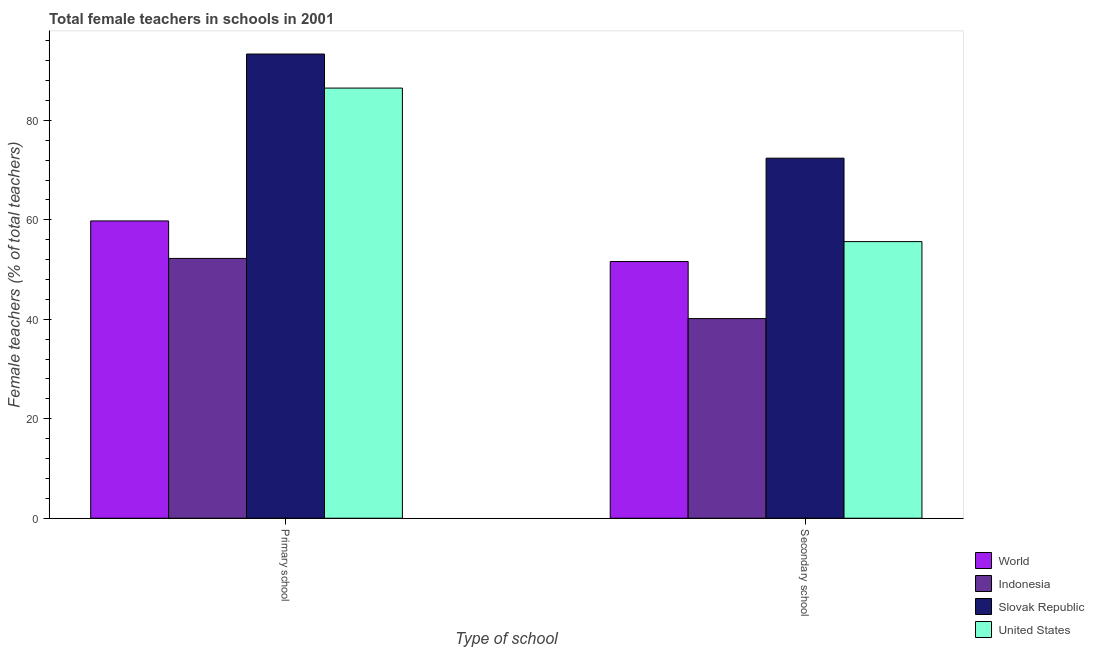How many groups of bars are there?
Keep it short and to the point. 2. Are the number of bars on each tick of the X-axis equal?
Offer a very short reply. Yes. How many bars are there on the 2nd tick from the left?
Your answer should be compact. 4. How many bars are there on the 1st tick from the right?
Your answer should be compact. 4. What is the label of the 1st group of bars from the left?
Offer a terse response. Primary school. What is the percentage of female teachers in primary schools in World?
Your answer should be compact. 59.78. Across all countries, what is the maximum percentage of female teachers in primary schools?
Offer a very short reply. 93.33. Across all countries, what is the minimum percentage of female teachers in primary schools?
Ensure brevity in your answer.  52.24. In which country was the percentage of female teachers in secondary schools maximum?
Keep it short and to the point. Slovak Republic. What is the total percentage of female teachers in primary schools in the graph?
Offer a very short reply. 291.83. What is the difference between the percentage of female teachers in primary schools in World and that in United States?
Provide a short and direct response. -26.71. What is the difference between the percentage of female teachers in secondary schools in United States and the percentage of female teachers in primary schools in Indonesia?
Your answer should be very brief. 3.38. What is the average percentage of female teachers in secondary schools per country?
Provide a succinct answer. 54.94. What is the difference between the percentage of female teachers in secondary schools and percentage of female teachers in primary schools in World?
Your answer should be compact. -8.17. What is the ratio of the percentage of female teachers in primary schools in World to that in United States?
Offer a terse response. 0.69. Is the percentage of female teachers in primary schools in World less than that in United States?
Your answer should be compact. Yes. In how many countries, is the percentage of female teachers in secondary schools greater than the average percentage of female teachers in secondary schools taken over all countries?
Offer a very short reply. 2. What does the 4th bar from the left in Secondary school represents?
Make the answer very short. United States. How many bars are there?
Your response must be concise. 8. Are all the bars in the graph horizontal?
Keep it short and to the point. No. How many countries are there in the graph?
Ensure brevity in your answer.  4. What is the difference between two consecutive major ticks on the Y-axis?
Offer a terse response. 20. Where does the legend appear in the graph?
Your answer should be very brief. Bottom right. How many legend labels are there?
Offer a terse response. 4. What is the title of the graph?
Your response must be concise. Total female teachers in schools in 2001. What is the label or title of the X-axis?
Keep it short and to the point. Type of school. What is the label or title of the Y-axis?
Your answer should be compact. Female teachers (% of total teachers). What is the Female teachers (% of total teachers) of World in Primary school?
Offer a terse response. 59.78. What is the Female teachers (% of total teachers) in Indonesia in Primary school?
Give a very brief answer. 52.24. What is the Female teachers (% of total teachers) of Slovak Republic in Primary school?
Provide a short and direct response. 93.33. What is the Female teachers (% of total teachers) of United States in Primary school?
Keep it short and to the point. 86.49. What is the Female teachers (% of total teachers) of World in Secondary school?
Keep it short and to the point. 51.61. What is the Female teachers (% of total teachers) of Indonesia in Secondary school?
Your response must be concise. 40.14. What is the Female teachers (% of total teachers) in Slovak Republic in Secondary school?
Offer a very short reply. 72.39. What is the Female teachers (% of total teachers) in United States in Secondary school?
Provide a short and direct response. 55.62. Across all Type of school, what is the maximum Female teachers (% of total teachers) of World?
Offer a very short reply. 59.78. Across all Type of school, what is the maximum Female teachers (% of total teachers) in Indonesia?
Make the answer very short. 52.24. Across all Type of school, what is the maximum Female teachers (% of total teachers) in Slovak Republic?
Your answer should be compact. 93.33. Across all Type of school, what is the maximum Female teachers (% of total teachers) of United States?
Ensure brevity in your answer.  86.49. Across all Type of school, what is the minimum Female teachers (% of total teachers) in World?
Give a very brief answer. 51.61. Across all Type of school, what is the minimum Female teachers (% of total teachers) of Indonesia?
Provide a short and direct response. 40.14. Across all Type of school, what is the minimum Female teachers (% of total teachers) in Slovak Republic?
Make the answer very short. 72.39. Across all Type of school, what is the minimum Female teachers (% of total teachers) in United States?
Give a very brief answer. 55.62. What is the total Female teachers (% of total teachers) in World in the graph?
Ensure brevity in your answer.  111.39. What is the total Female teachers (% of total teachers) of Indonesia in the graph?
Your response must be concise. 92.38. What is the total Female teachers (% of total teachers) of Slovak Republic in the graph?
Provide a short and direct response. 165.72. What is the total Female teachers (% of total teachers) of United States in the graph?
Your answer should be very brief. 142.1. What is the difference between the Female teachers (% of total teachers) of World in Primary school and that in Secondary school?
Provide a short and direct response. 8.17. What is the difference between the Female teachers (% of total teachers) in Indonesia in Primary school and that in Secondary school?
Your response must be concise. 12.1. What is the difference between the Female teachers (% of total teachers) in Slovak Republic in Primary school and that in Secondary school?
Offer a very short reply. 20.94. What is the difference between the Female teachers (% of total teachers) in United States in Primary school and that in Secondary school?
Ensure brevity in your answer.  30.87. What is the difference between the Female teachers (% of total teachers) in World in Primary school and the Female teachers (% of total teachers) in Indonesia in Secondary school?
Your response must be concise. 19.64. What is the difference between the Female teachers (% of total teachers) of World in Primary school and the Female teachers (% of total teachers) of Slovak Republic in Secondary school?
Provide a short and direct response. -12.61. What is the difference between the Female teachers (% of total teachers) of World in Primary school and the Female teachers (% of total teachers) of United States in Secondary school?
Offer a very short reply. 4.16. What is the difference between the Female teachers (% of total teachers) in Indonesia in Primary school and the Female teachers (% of total teachers) in Slovak Republic in Secondary school?
Provide a short and direct response. -20.15. What is the difference between the Female teachers (% of total teachers) of Indonesia in Primary school and the Female teachers (% of total teachers) of United States in Secondary school?
Make the answer very short. -3.38. What is the difference between the Female teachers (% of total teachers) of Slovak Republic in Primary school and the Female teachers (% of total teachers) of United States in Secondary school?
Provide a succinct answer. 37.71. What is the average Female teachers (% of total teachers) in World per Type of school?
Give a very brief answer. 55.69. What is the average Female teachers (% of total teachers) in Indonesia per Type of school?
Give a very brief answer. 46.19. What is the average Female teachers (% of total teachers) in Slovak Republic per Type of school?
Offer a terse response. 82.86. What is the average Female teachers (% of total teachers) in United States per Type of school?
Your response must be concise. 71.05. What is the difference between the Female teachers (% of total teachers) in World and Female teachers (% of total teachers) in Indonesia in Primary school?
Your response must be concise. 7.54. What is the difference between the Female teachers (% of total teachers) of World and Female teachers (% of total teachers) of Slovak Republic in Primary school?
Your answer should be compact. -33.55. What is the difference between the Female teachers (% of total teachers) of World and Female teachers (% of total teachers) of United States in Primary school?
Ensure brevity in your answer.  -26.71. What is the difference between the Female teachers (% of total teachers) in Indonesia and Female teachers (% of total teachers) in Slovak Republic in Primary school?
Ensure brevity in your answer.  -41.09. What is the difference between the Female teachers (% of total teachers) of Indonesia and Female teachers (% of total teachers) of United States in Primary school?
Ensure brevity in your answer.  -34.25. What is the difference between the Female teachers (% of total teachers) of Slovak Republic and Female teachers (% of total teachers) of United States in Primary school?
Your response must be concise. 6.85. What is the difference between the Female teachers (% of total teachers) of World and Female teachers (% of total teachers) of Indonesia in Secondary school?
Make the answer very short. 11.47. What is the difference between the Female teachers (% of total teachers) of World and Female teachers (% of total teachers) of Slovak Republic in Secondary school?
Make the answer very short. -20.78. What is the difference between the Female teachers (% of total teachers) of World and Female teachers (% of total teachers) of United States in Secondary school?
Give a very brief answer. -4.01. What is the difference between the Female teachers (% of total teachers) of Indonesia and Female teachers (% of total teachers) of Slovak Republic in Secondary school?
Provide a succinct answer. -32.25. What is the difference between the Female teachers (% of total teachers) of Indonesia and Female teachers (% of total teachers) of United States in Secondary school?
Your answer should be compact. -15.48. What is the difference between the Female teachers (% of total teachers) in Slovak Republic and Female teachers (% of total teachers) in United States in Secondary school?
Give a very brief answer. 16.77. What is the ratio of the Female teachers (% of total teachers) in World in Primary school to that in Secondary school?
Keep it short and to the point. 1.16. What is the ratio of the Female teachers (% of total teachers) in Indonesia in Primary school to that in Secondary school?
Your response must be concise. 1.3. What is the ratio of the Female teachers (% of total teachers) of Slovak Republic in Primary school to that in Secondary school?
Offer a very short reply. 1.29. What is the ratio of the Female teachers (% of total teachers) of United States in Primary school to that in Secondary school?
Ensure brevity in your answer.  1.55. What is the difference between the highest and the second highest Female teachers (% of total teachers) in World?
Your answer should be very brief. 8.17. What is the difference between the highest and the second highest Female teachers (% of total teachers) in Indonesia?
Your answer should be very brief. 12.1. What is the difference between the highest and the second highest Female teachers (% of total teachers) in Slovak Republic?
Your answer should be compact. 20.94. What is the difference between the highest and the second highest Female teachers (% of total teachers) of United States?
Offer a terse response. 30.87. What is the difference between the highest and the lowest Female teachers (% of total teachers) in World?
Keep it short and to the point. 8.17. What is the difference between the highest and the lowest Female teachers (% of total teachers) of Indonesia?
Provide a short and direct response. 12.1. What is the difference between the highest and the lowest Female teachers (% of total teachers) of Slovak Republic?
Offer a terse response. 20.94. What is the difference between the highest and the lowest Female teachers (% of total teachers) in United States?
Provide a short and direct response. 30.87. 